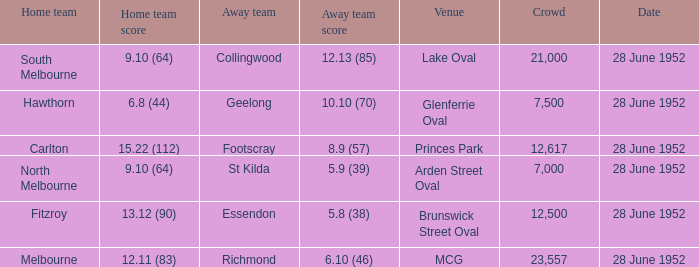What is the away team when north melbourne is at home? St Kilda. 